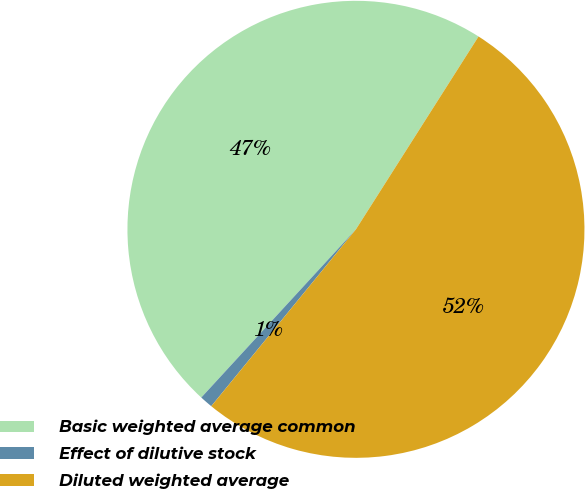<chart> <loc_0><loc_0><loc_500><loc_500><pie_chart><fcel>Basic weighted average common<fcel>Effect of dilutive stock<fcel>Diluted weighted average<nl><fcel>47.18%<fcel>0.92%<fcel>51.9%<nl></chart> 